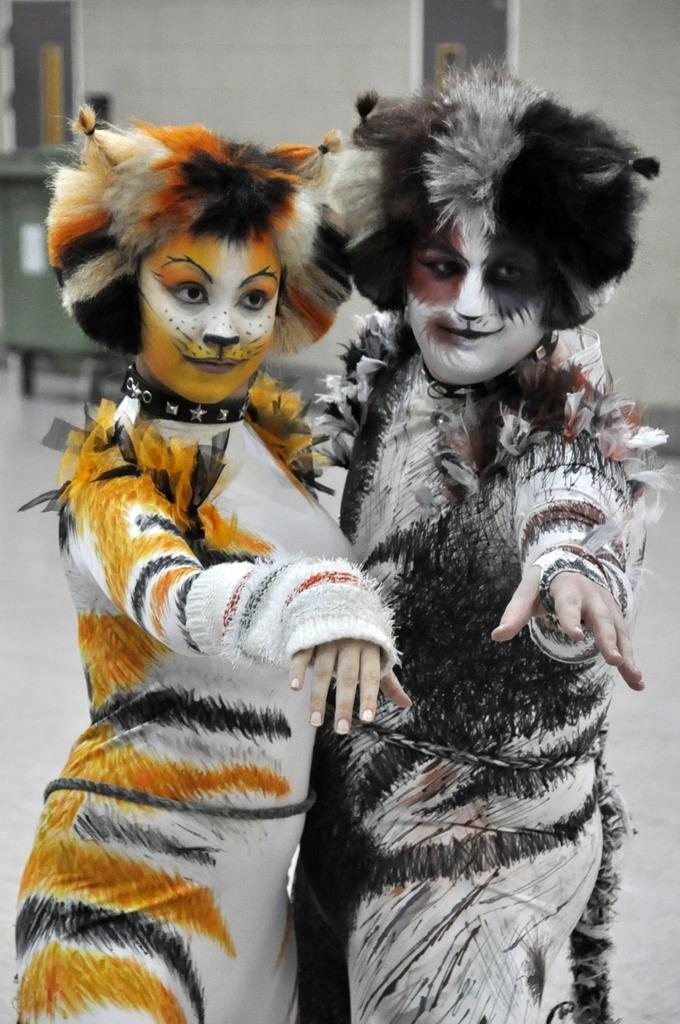How many people are in the image? There are two people in the image. What are the people doing in the image? The people are standing. What are the people wearing in the image? The people are wearing different costumes. Can you describe the background of the image? The background of the image is blurred. What type of box can be seen in the image? There is no box present in the image. Who is the representative of the people in the image? There is no representative mentioned or depicted in the image. 